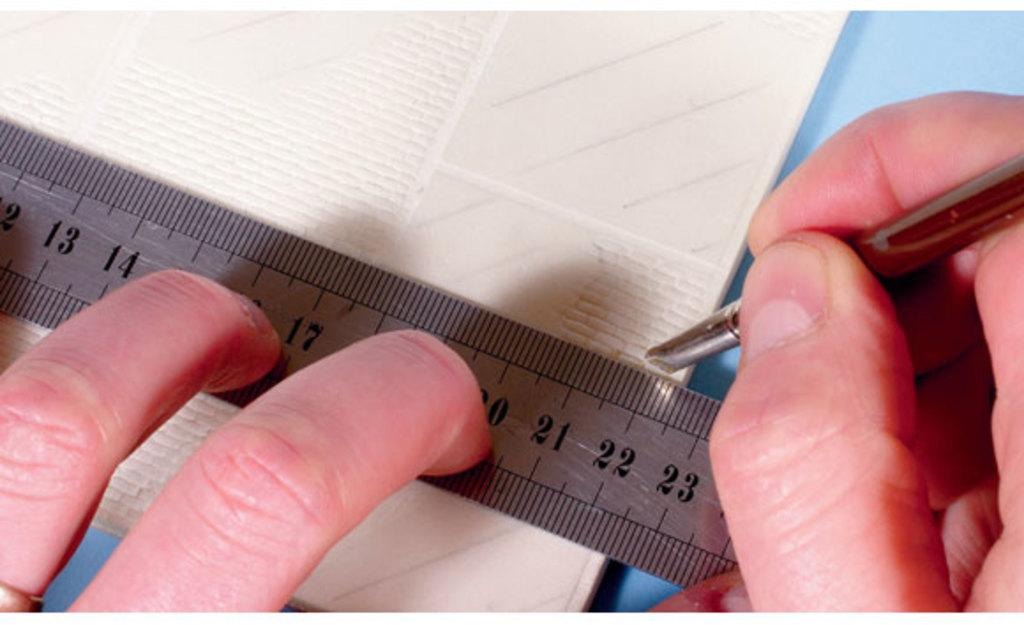<image>
Summarize the visual content of the image. The three number that are shown on the ruler 